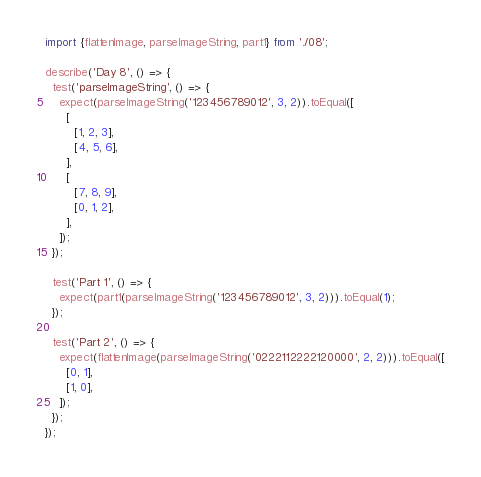<code> <loc_0><loc_0><loc_500><loc_500><_TypeScript_>import {flattenImage, parseImageString, part1} from './08';

describe('Day 8', () => {
  test('parseImageString', () => {
    expect(parseImageString('123456789012', 3, 2)).toEqual([
      [
        [1, 2, 3],
        [4, 5, 6],
      ],
      [
        [7, 8, 9],
        [0, 1, 2],
      ],
    ]);
  });

  test('Part 1', () => {
    expect(part1(parseImageString('123456789012', 3, 2))).toEqual(1);
  });

  test('Part 2', () => {
    expect(flattenImage(parseImageString('0222112222120000', 2, 2))).toEqual([
      [0, 1],
      [1, 0],
    ]);
  });
});
</code> 